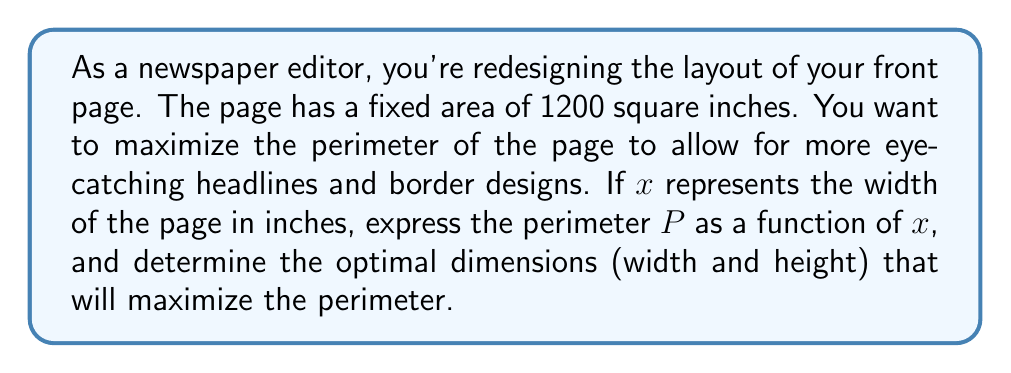Solve this math problem. Let's approach this step-by-step:

1) Given:
   - The area of the page is fixed at 1200 square inches.
   - Let $x$ be the width of the page in inches.
   - Let $y$ be the height of the page in inches.

2) From the area constraint:
   $xy = 1200$
   $y = \frac{1200}{x}$

3) The perimeter of a rectangle is given by:
   $P = 2x + 2y$

4) Substituting $y$ with $\frac{1200}{x}$:
   $P = 2x + 2(\frac{1200}{x})$
   $P = 2x + \frac{2400}{x}$

5) To find the maximum value of $P$, we need to find where $\frac{dP}{dx} = 0$:
   $\frac{dP}{dx} = 2 - \frac{2400}{x^2}$

6) Setting this equal to zero:
   $2 - \frac{2400}{x^2} = 0$
   $\frac{2400}{x^2} = 2$
   $x^2 = 1200$
   $x = \sqrt{1200} = 20\sqrt{3} \approx 34.64$ inches

7) To find $y$, we use the area constraint:
   $y = \frac{1200}{x} = \frac{1200}{20\sqrt{3}} = 10\sqrt{3} \approx 17.32$ inches

8) The maximum perimeter can be calculated by substituting $x = 20\sqrt{3}$ into the perimeter function:
   $P = 2(20\sqrt{3}) + \frac{2400}{20\sqrt{3}} = 40\sqrt{3} + 40\sqrt{3} = 80\sqrt{3} \approx 138.56$ inches
Answer: The optimal dimensions for the newspaper page are approximately 34.64 inches wide by 17.32 inches high, resulting in a maximum perimeter of approximately 138.56 inches. 